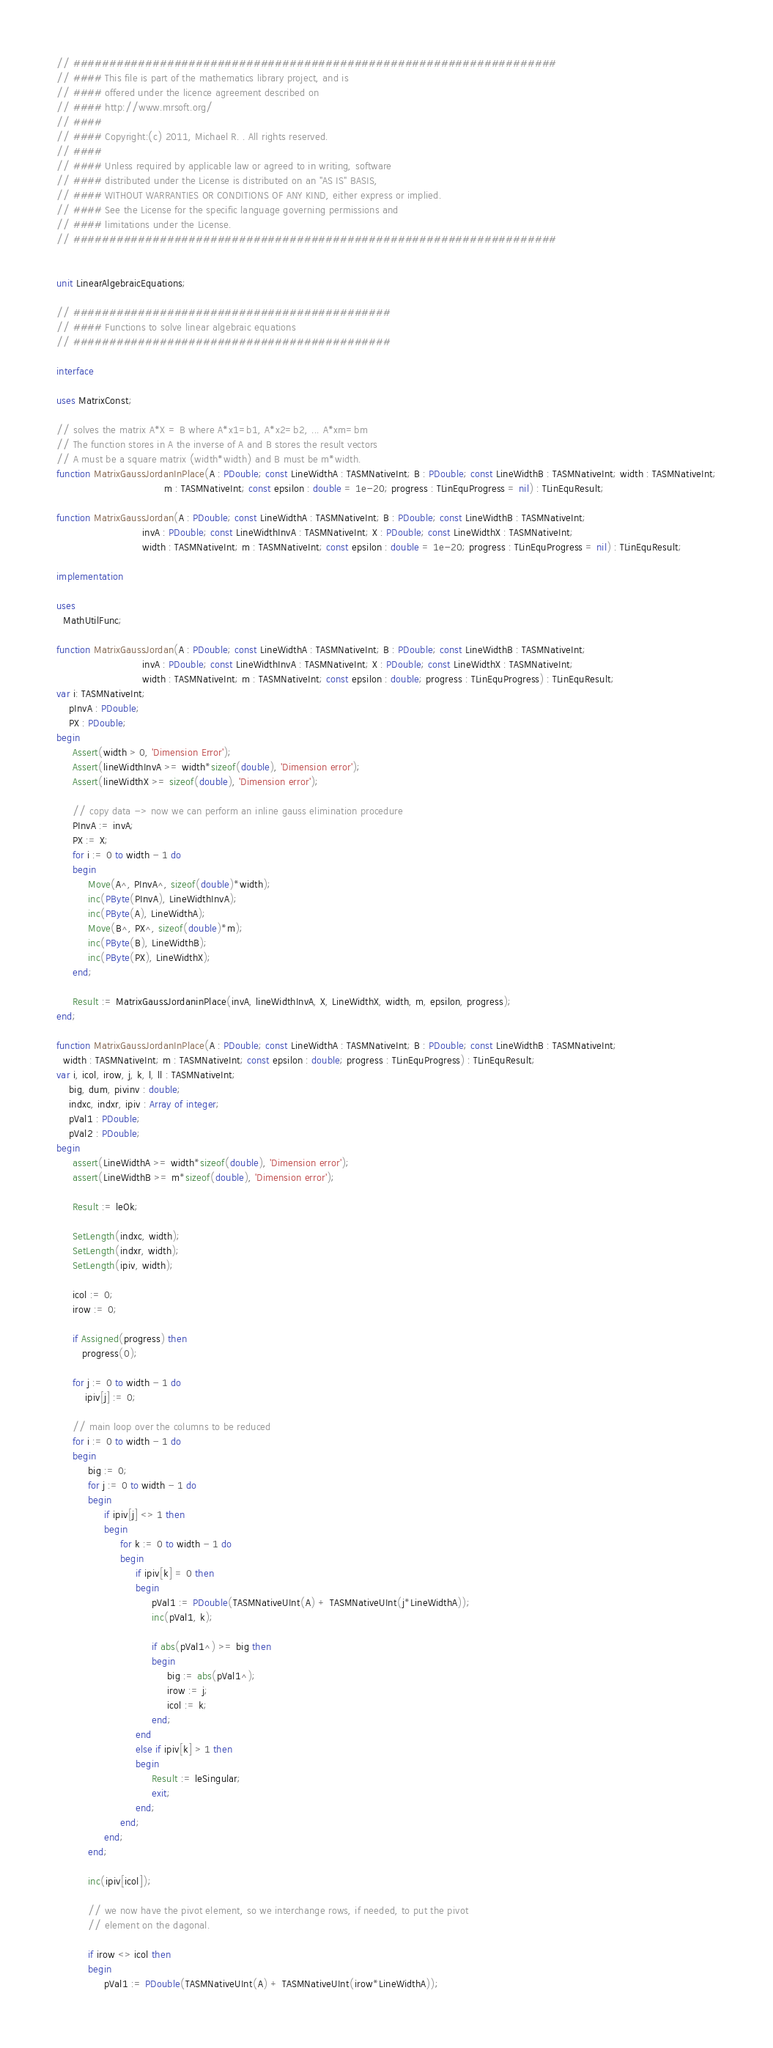<code> <loc_0><loc_0><loc_500><loc_500><_Pascal_>// ###################################################################
// #### This file is part of the mathematics library project, and is
// #### offered under the licence agreement described on
// #### http://www.mrsoft.org/
// ####
// #### Copyright:(c) 2011, Michael R. . All rights reserved.
// ####
// #### Unless required by applicable law or agreed to in writing, software
// #### distributed under the License is distributed on an "AS IS" BASIS,
// #### WITHOUT WARRANTIES OR CONDITIONS OF ANY KIND, either express or implied.
// #### See the License for the specific language governing permissions and
// #### limitations under the License.
// ###################################################################


unit LinearAlgebraicEquations;

// ############################################
// #### Functions to solve linear algebraic equations
// ############################################

interface

uses MatrixConst;

// solves the matrix A*X = B where A*x1=b1, A*x2=b2, ... A*xm=bm
// The function stores in A the inverse of A and B stores the result vectors
// A must be a square matrix (width*width) and B must be m*width.
function MatrixGaussJordanInPlace(A : PDouble; const LineWidthA : TASMNativeInt; B : PDouble; const LineWidthB : TASMNativeInt; width : TASMNativeInt;
                                  m : TASMNativeInt; const epsilon : double = 1e-20; progress : TLinEquProgress = nil) : TLinEquResult;

function MatrixGaussJordan(A : PDouble; const LineWidthA : TASMNativeInt; B : PDouble; const LineWidthB : TASMNativeInt;
                           invA : PDouble; const LineWidthInvA : TASMNativeInt; X : PDouble; const LineWidthX : TASMNativeInt;
                           width : TASMNativeInt; m : TASMNativeInt; const epsilon : double = 1e-20; progress : TLinEquProgress = nil) : TLinEquResult;

implementation

uses
  MathUtilFunc;

function MatrixGaussJordan(A : PDouble; const LineWidthA : TASMNativeInt; B : PDouble; const LineWidthB : TASMNativeInt;
                           invA : PDouble; const LineWidthInvA : TASMNativeInt; X : PDouble; const LineWidthX : TASMNativeInt;
                           width : TASMNativeInt; m : TASMNativeInt; const epsilon : double; progress : TLinEquProgress) : TLinEquResult;
var i: TASMNativeInt;
    pInvA : PDouble;
    PX : PDouble;
begin
     Assert(width > 0, 'Dimension Error');
     Assert(lineWidthInvA >= width*sizeof(double), 'Dimension error');
     Assert(lineWidthX >= sizeof(double), 'Dimension error');

     // copy data -> now we can perform an inline gauss elimination procedure
     PInvA := invA;
     PX := X;
     for i := 0 to width - 1 do
     begin
          Move(A^, PInvA^, sizeof(double)*width);
          inc(PByte(PInvA), LineWidthInvA);
          inc(PByte(A), LineWidthA);
          Move(B^, PX^, sizeof(double)*m);
          inc(PByte(B), LineWidthB);
          inc(PByte(PX), LineWidthX);
     end;

     Result := MatrixGaussJordaninPlace(invA, lineWidthInvA, X, LineWidthX, width, m, epsilon, progress);
end;

function MatrixGaussJordanInPlace(A : PDouble; const LineWidthA : TASMNativeInt; B : PDouble; const LineWidthB : TASMNativeInt;
  width : TASMNativeInt; m : TASMNativeInt; const epsilon : double; progress : TLinEquProgress) : TLinEquResult;
var i, icol, irow, j, k, l, ll : TASMNativeInt;
    big, dum, pivinv : double;
    indxc, indxr, ipiv : Array of integer;
    pVal1 : PDouble;
    pVal2 : PDouble;
begin
     assert(LineWidthA >= width*sizeof(double), 'Dimension error');
     assert(LineWidthB >= m*sizeof(double), 'Dimension error');

     Result := leOk;

     SetLength(indxc, width);
     SetLength(indxr, width);
     SetLength(ipiv, width);

     icol := 0;
     irow := 0;

     if Assigned(progress) then
        progress(0);

     for j := 0 to width - 1 do
         ipiv[j] := 0;

     // main loop over the columns to be reduced
     for i := 0 to width - 1 do
     begin
          big := 0;
          for j := 0 to width - 1 do
          begin
               if ipiv[j] <> 1 then
               begin
                    for k := 0 to width - 1 do
                    begin
                         if ipiv[k] = 0 then
                         begin
                              pVal1 := PDouble(TASMNativeUInt(A) + TASMNativeUInt(j*LineWidthA));
                              inc(pVal1, k);

                              if abs(pVal1^) >= big then
                              begin
                                   big := abs(pVal1^);
                                   irow := j;
                                   icol := k;
                              end;
                         end
                         else if ipiv[k] > 1 then
                         begin
                              Result := leSingular;
                              exit;
                         end;
                    end;
               end;
          end;

          inc(ipiv[icol]);

          // we now have the pivot element, so we interchange rows, if needed, to put the pivot
          // element on the dagonal.

          if irow <> icol then
          begin
               pVal1 := PDouble(TASMNativeUInt(A) + TASMNativeUInt(irow*LineWidthA));</code> 